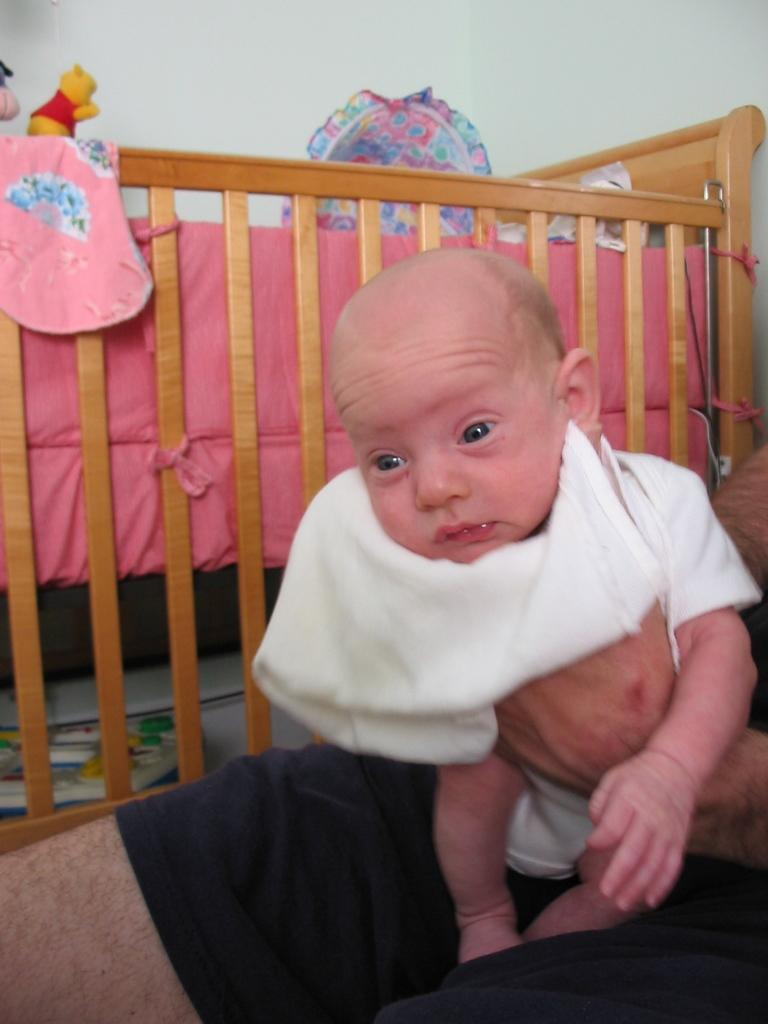What is the person in the image holding? The person is holding a baby. What type of furniture can be seen in the background? There is wooden furniture in the background. What can be found on the wooden furniture? There are toys on the wooden furniture. What type of sign is visible in the image? There is no sign visible in the image. Can you tell me how many people are joining the person holding the baby in the image? There is no indication of additional people joining the person holding the baby in the image. 